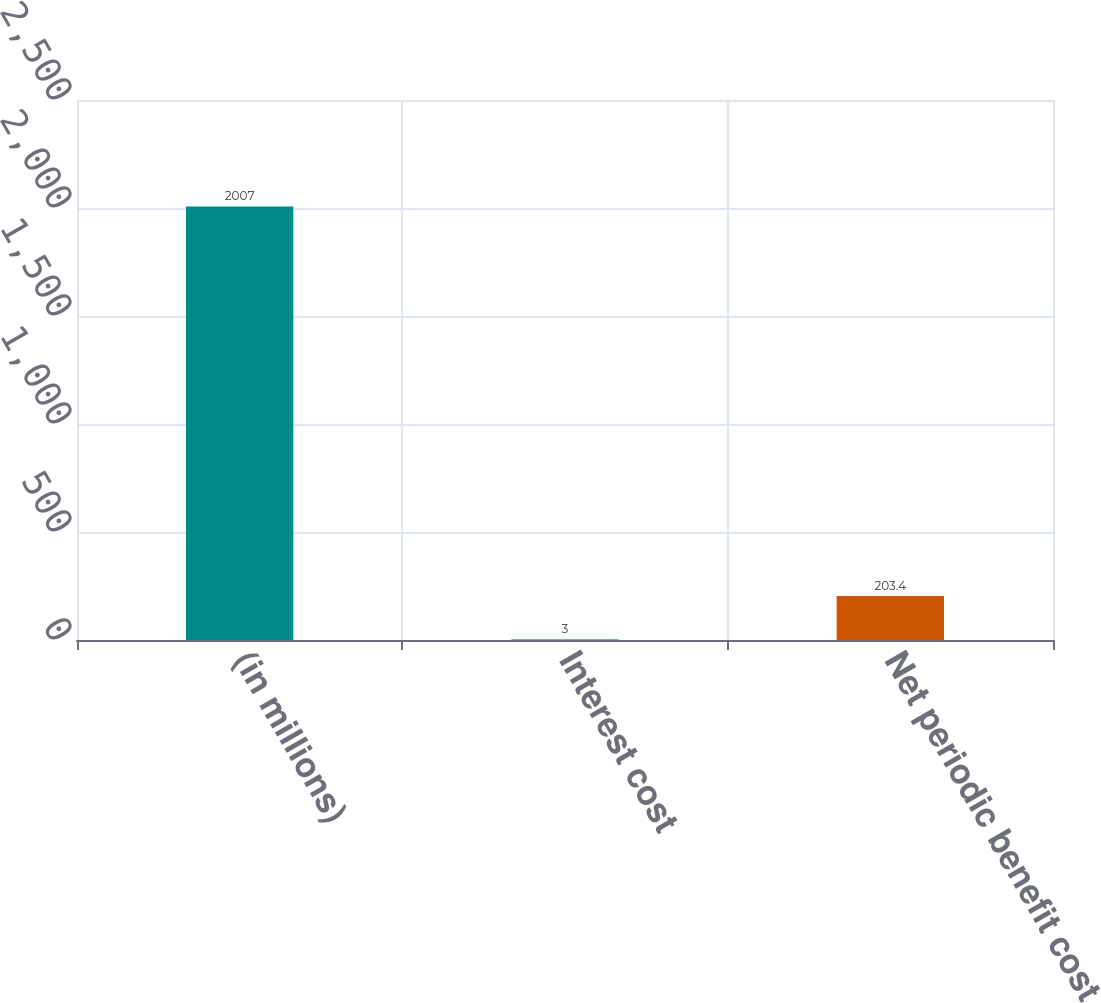<chart> <loc_0><loc_0><loc_500><loc_500><bar_chart><fcel>(in millions)<fcel>Interest cost<fcel>Net periodic benefit cost<nl><fcel>2007<fcel>3<fcel>203.4<nl></chart> 